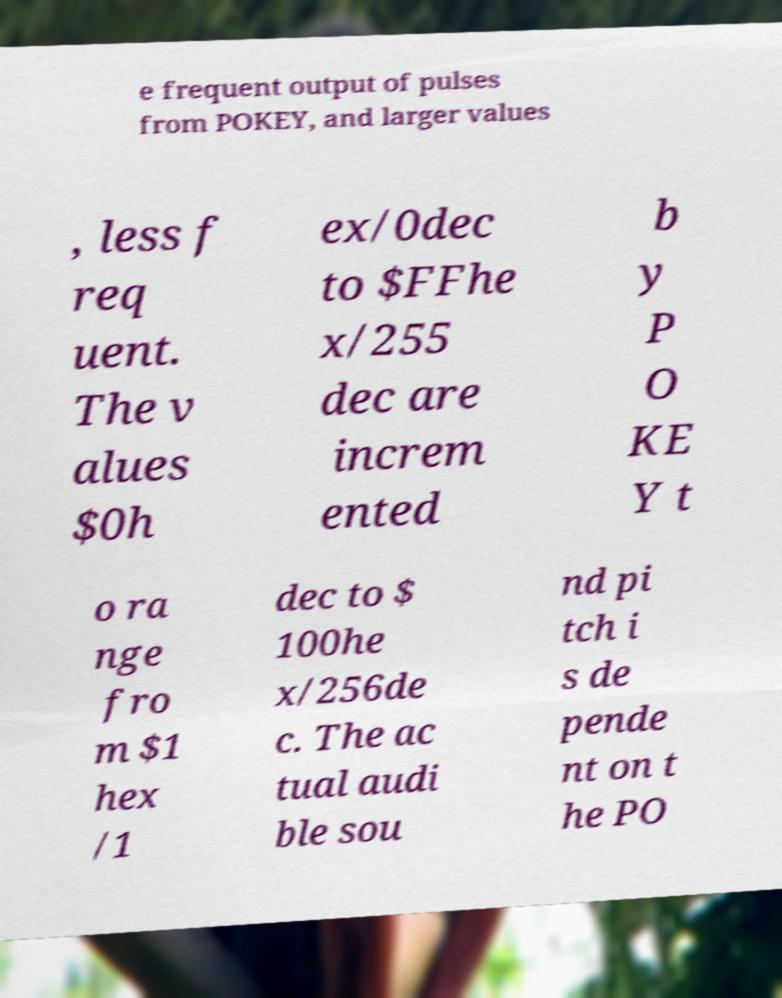Can you read and provide the text displayed in the image?This photo seems to have some interesting text. Can you extract and type it out for me? e frequent output of pulses from POKEY, and larger values , less f req uent. The v alues $0h ex/0dec to $FFhe x/255 dec are increm ented b y P O KE Y t o ra nge fro m $1 hex /1 dec to $ 100he x/256de c. The ac tual audi ble sou nd pi tch i s de pende nt on t he PO 